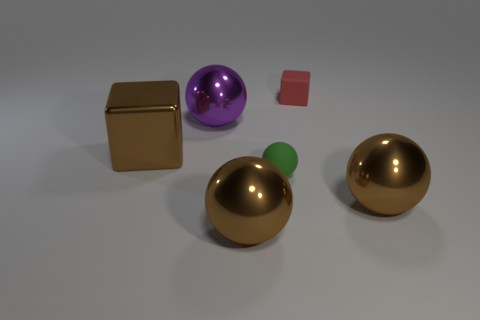How many objects are there in total? Including every item, there are five objects present in the image. Can you describe the size relationship between these objects? Certainly, there are two large spheres, a large cube, a smaller sphere, and a tiny cube. The large sphere and cube appear to be about the same size, dominating the composition. 